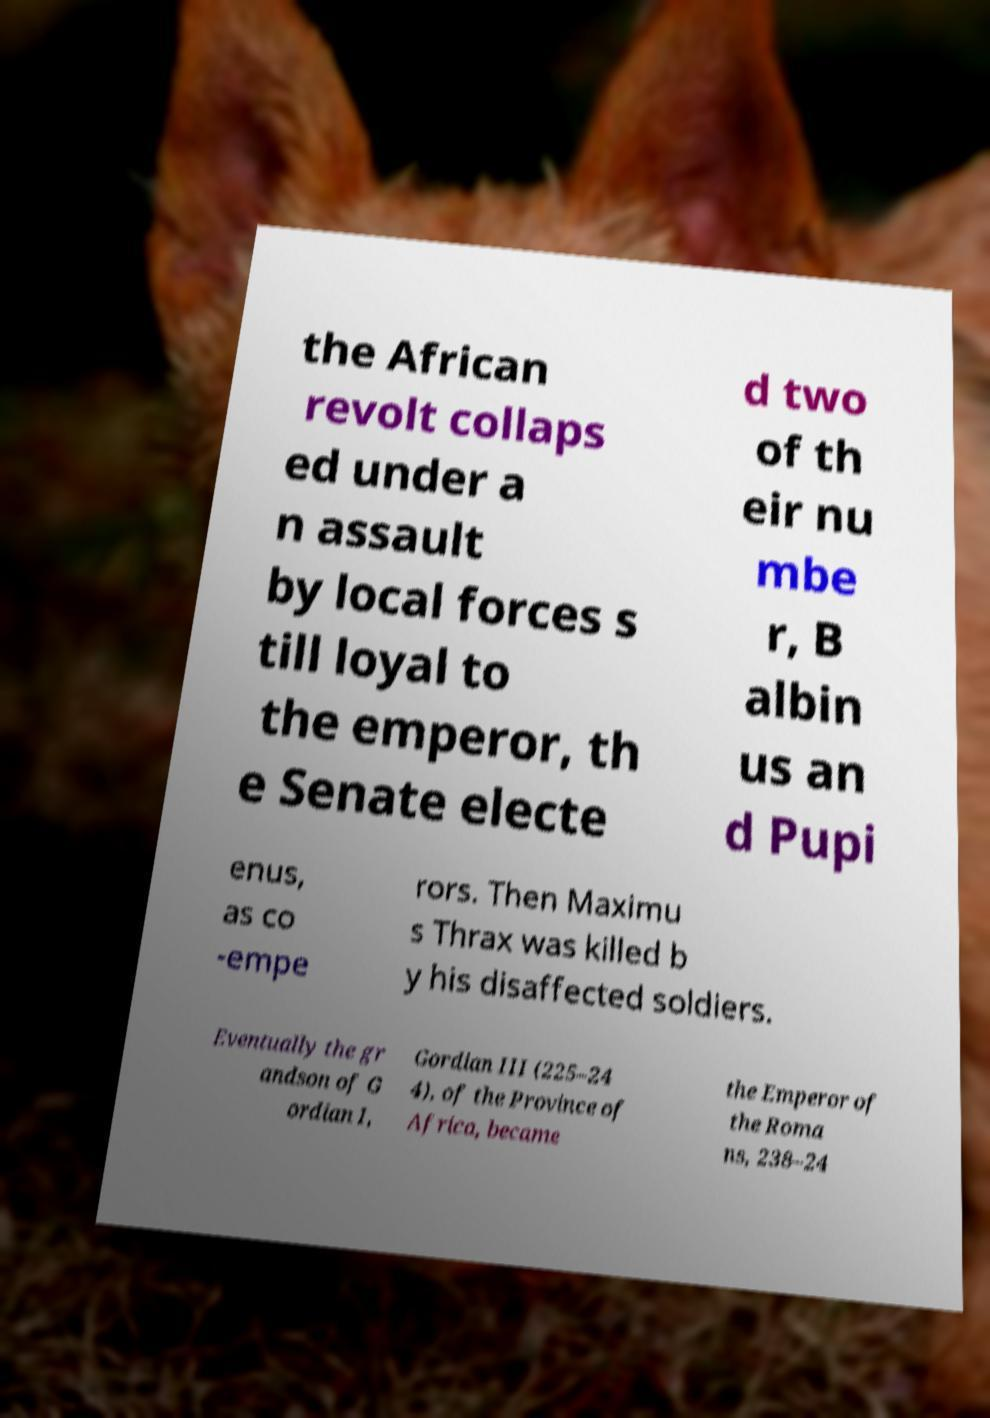There's text embedded in this image that I need extracted. Can you transcribe it verbatim? the African revolt collaps ed under a n assault by local forces s till loyal to the emperor, th e Senate electe d two of th eir nu mbe r, B albin us an d Pupi enus, as co -empe rors. Then Maximu s Thrax was killed b y his disaffected soldiers. Eventually the gr andson of G ordian I, Gordian III (225–24 4), of the Province of Africa, became the Emperor of the Roma ns, 238–24 